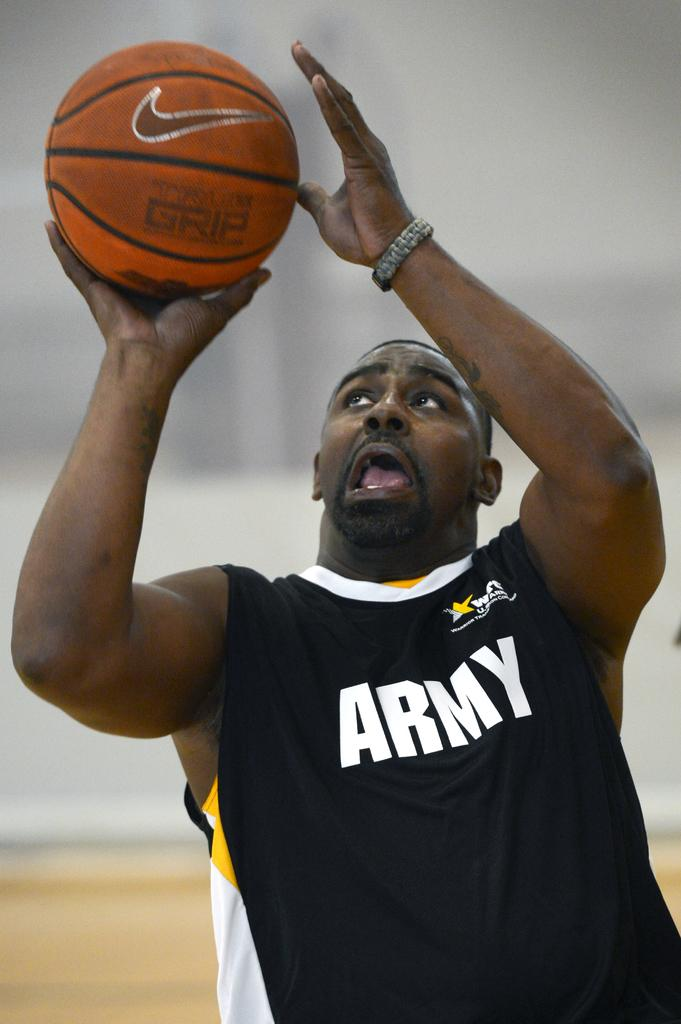<image>
Summarize the visual content of the image. A basketball player wearing a top that says "ARMY", looking up with a ball in his right hand. 